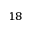Convert formula to latex. <formula><loc_0><loc_0><loc_500><loc_500>^ { 1 8 }</formula> 